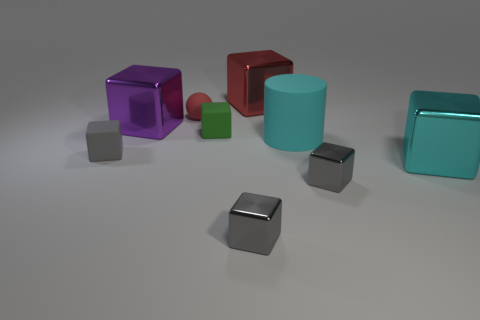Is the number of cyan cylinders to the right of the cyan matte object less than the number of tiny green rubber cubes?
Your answer should be compact. Yes. What is the color of the matte block right of the tiny matte cube that is in front of the tiny green cube on the right side of the tiny red matte thing?
Keep it short and to the point. Green. How many metallic objects are either tiny blue things or cyan blocks?
Provide a short and direct response. 1. Is the purple cube the same size as the sphere?
Provide a succinct answer. No. Is the number of tiny green objects to the right of the green matte block less than the number of gray cubes that are to the left of the purple metallic block?
Your answer should be very brief. Yes. The cyan cylinder is what size?
Give a very brief answer. Large. How many large things are either shiny blocks or cyan rubber objects?
Give a very brief answer. 4. There is a matte cylinder; does it have the same size as the gray object to the left of the green matte block?
Provide a succinct answer. No. Is there anything else that has the same shape as the large purple metallic object?
Give a very brief answer. Yes. What number of big cyan spheres are there?
Keep it short and to the point. 0. 